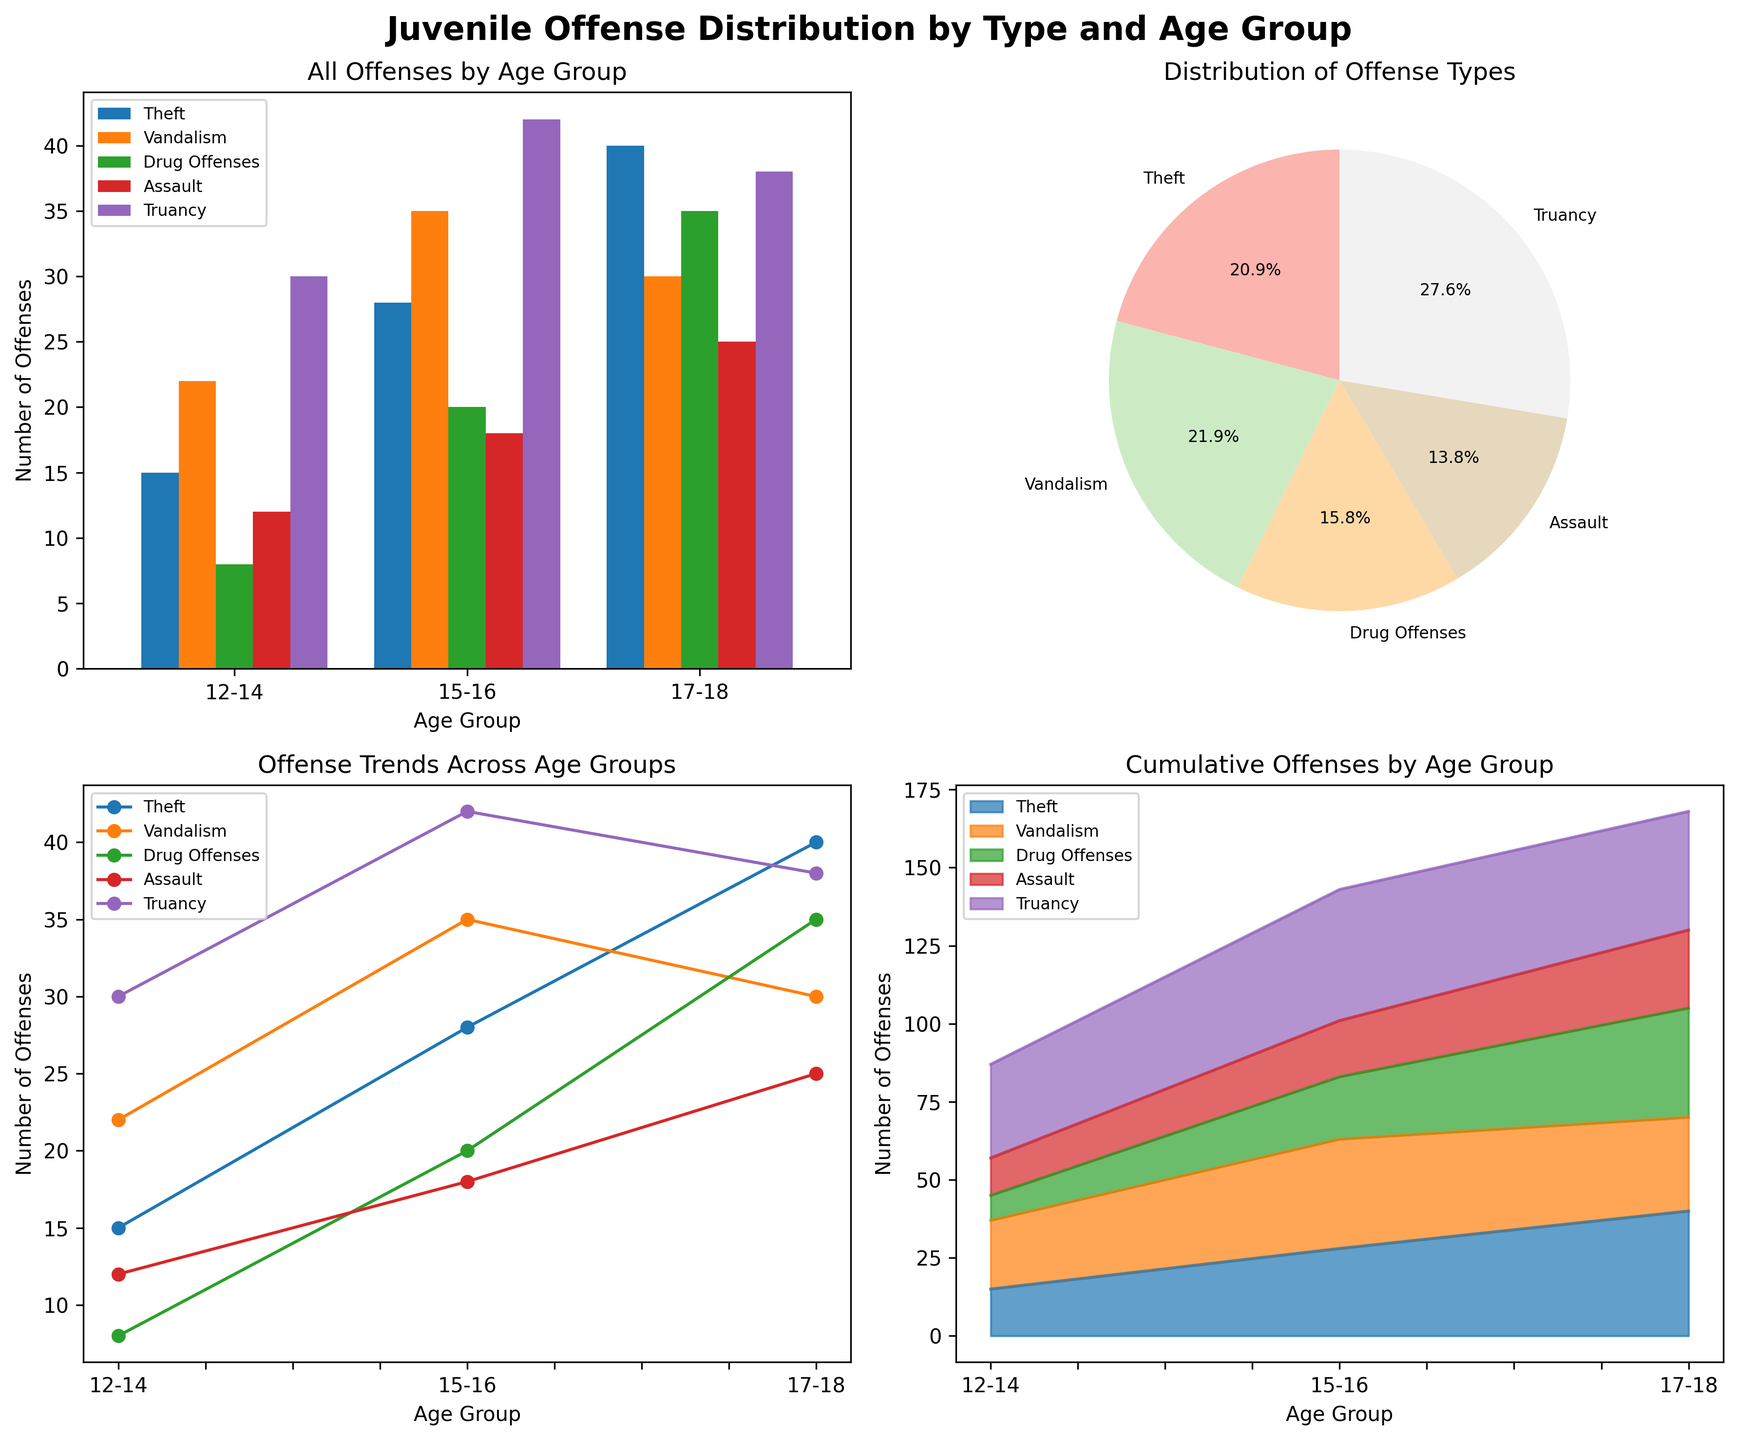what is the title of the figure? The title of the figure is typically the largest text at the top. In this case, it reads "Juvenile Offense Distribution by Type and Age Group".
Answer: Juvenile Offense Distribution by Type and Age Group How many offenses of each type are reported for the 15-16 age group in the bar plot? Look at the bar plot, find the bars corresponding to the 15-16 age group, and then identify the height of each bar for each offense type. The values should be 28 for Theft, 35 for Vandalism, 20 for Drug Offenses, 18 for Assault, and 42 for Truancy.
Answer: Theft: 28, Vandalism: 35, Drug Offenses: 20, Assault: 18, Truancy: 42 Which offense type has the highest percentage in the pie chart? Check the labels and their corresponding percentages in the pie chart. Truancy has the highest percentage among the offense types.
Answer: Truancy What trend do we observe for Drug Offenses across the age groups in the line plot? In the line plot, follow the line corresponding to Drug Offenses from the left to the right. The number of Drug Offenses increases steadily from 8 in the 12-14 age group to 35 in the 17-18 age group.
Answer: Increasing trend Which age group reports the most offenses in total according to the stacked area plot? Evaluate the stacked area plot by noting the height of the cumulative areas for each age group. The 17-18 age group has the tallest cumulative area, indicating the most offenses.
Answer: 17-18 What is the total number of Assault offenses reported across all age groups? Sum the number of Assault offenses from the bar plot or data: 12 (12-14 age group) + 18 (15-16 age group) + 25 (17-18 age group). The total is 12 + 18 + 25 = 55.
Answer: 55 Is the number of Theft offenses greater than the number of Drug Offenses for the 15-16 age group? Compare the heights of the bars for Theft and Drug Offenses in the 15-16 age group. Theft (28) is greater than Drug Offenses (20).
Answer: Yes What percentage of the total offenses does Vandalism constitute, as shown in the pie chart? Refer to the pie chart and look at the percentage label for Vandalism. It shows a certain percentage of the total offenses. The label reads Vandalism (22.8%).
Answer: 22.8% How does the number of Vandalism offenses compare between the 12-14 and 15-16 age groups in the bar plot? Compare the heights of the Vandalism bars in the bar plot for the 12-14 and 15-16 age groups. For the 12-14 age group, it's 22; for the 15-16 age group, it's 35. Thus, 15-16 is higher than 12-14.
Answer: 15-16 > 12-14 What do you observe about Truancy offenses as per the stacked area plot across different age groups? In the stacked area plot, follow the section representing Truancy (the topmost shaded area). Truancy shows an increase from the 12-14 to the 15-16 age group but slightly decreases in the 17-18 age group.
Answer: Increases from 12-14 to 15-16, then slightly decreases in 17-18 